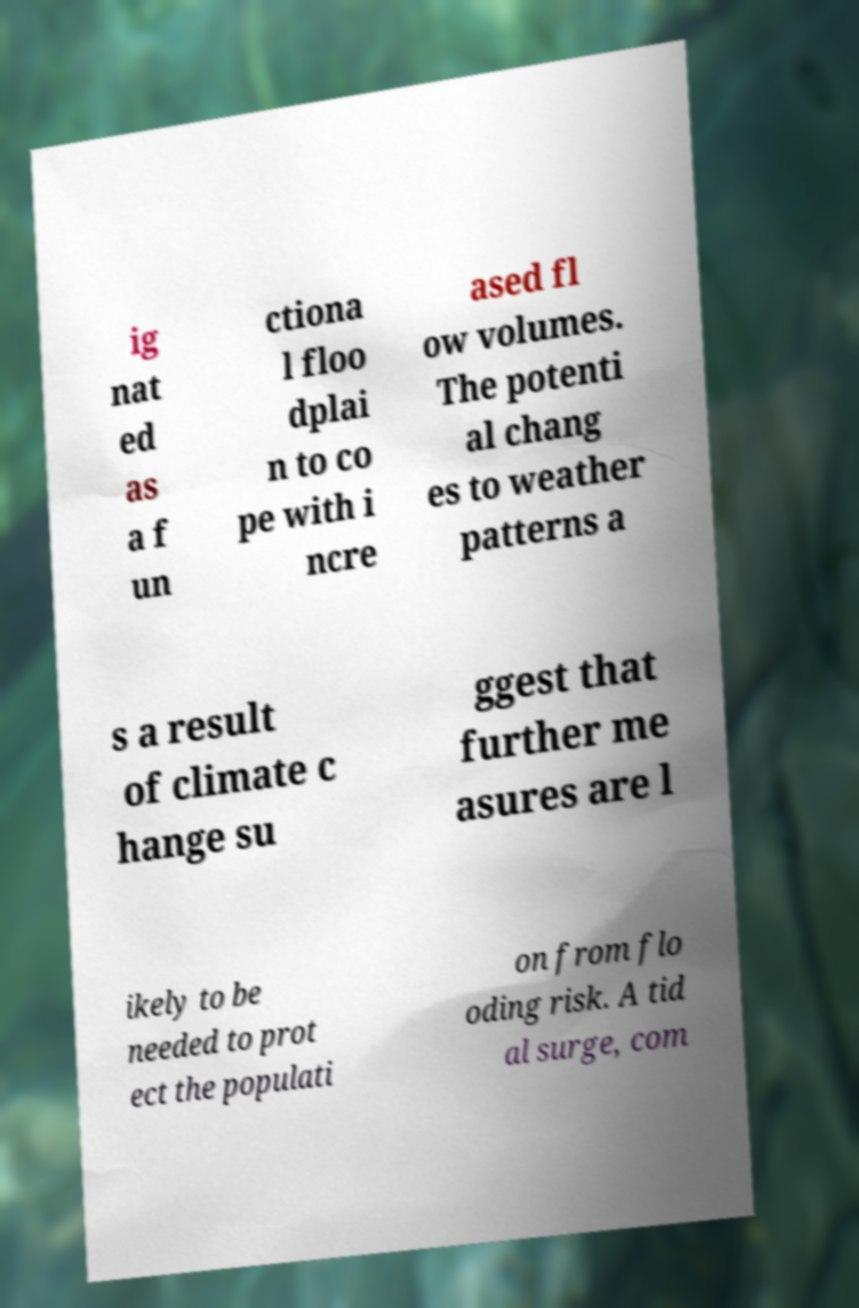Could you extract and type out the text from this image? ig nat ed as a f un ctiona l floo dplai n to co pe with i ncre ased fl ow volumes. The potenti al chang es to weather patterns a s a result of climate c hange su ggest that further me asures are l ikely to be needed to prot ect the populati on from flo oding risk. A tid al surge, com 